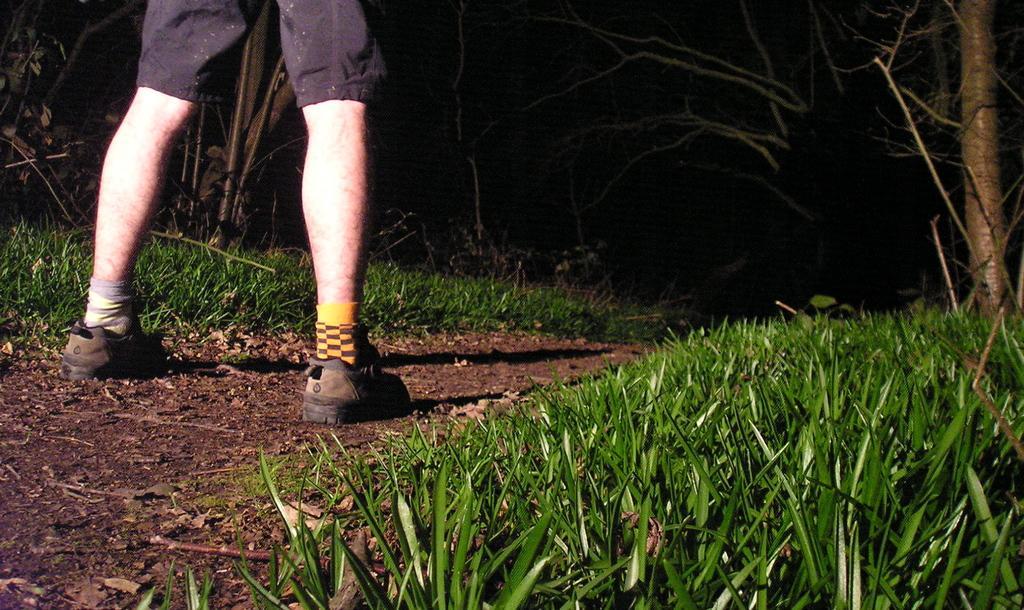Describe this image in one or two sentences. In this picture we can see legs of a person, and the person wore shoes, and also we can see grass and trees. 